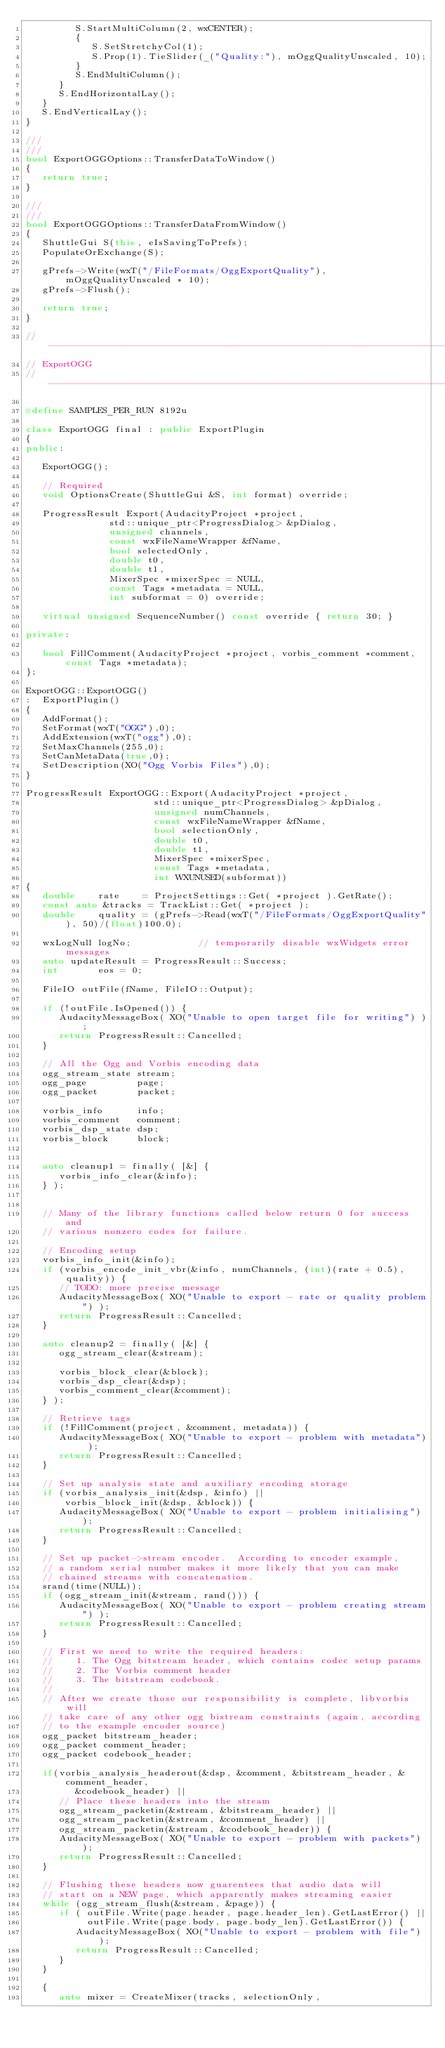<code> <loc_0><loc_0><loc_500><loc_500><_C++_>         S.StartMultiColumn(2, wxCENTER);
         {
            S.SetStretchyCol(1);
            S.Prop(1).TieSlider(_("Quality:"), mOggQualityUnscaled, 10);
         }
         S.EndMultiColumn();
      }
      S.EndHorizontalLay();
   }
   S.EndVerticalLay();
}

///
///
bool ExportOGGOptions::TransferDataToWindow()
{
   return true;
}

///
///
bool ExportOGGOptions::TransferDataFromWindow()
{
   ShuttleGui S(this, eIsSavingToPrefs);
   PopulateOrExchange(S);

   gPrefs->Write(wxT("/FileFormats/OggExportQuality"),mOggQualityUnscaled * 10);
   gPrefs->Flush();

   return true;
}

//----------------------------------------------------------------------------
// ExportOGG
//----------------------------------------------------------------------------

#define SAMPLES_PER_RUN 8192u

class ExportOGG final : public ExportPlugin
{
public:

   ExportOGG();

   // Required
   void OptionsCreate(ShuttleGui &S, int format) override;

   ProgressResult Export(AudacityProject *project,
               std::unique_ptr<ProgressDialog> &pDialog,
               unsigned channels,
               const wxFileNameWrapper &fName,
               bool selectedOnly,
               double t0,
               double t1,
               MixerSpec *mixerSpec = NULL,
               const Tags *metadata = NULL,
               int subformat = 0) override;

   virtual unsigned SequenceNumber() const override { return 30; }

private:

   bool FillComment(AudacityProject *project, vorbis_comment *comment, const Tags *metadata);
};

ExportOGG::ExportOGG()
:  ExportPlugin()
{
   AddFormat();
   SetFormat(wxT("OGG"),0);
   AddExtension(wxT("ogg"),0);
   SetMaxChannels(255,0);
   SetCanMetaData(true,0);
   SetDescription(XO("Ogg Vorbis Files"),0);
}

ProgressResult ExportOGG::Export(AudacityProject *project,
                       std::unique_ptr<ProgressDialog> &pDialog,
                       unsigned numChannels,
                       const wxFileNameWrapper &fName,
                       bool selectionOnly,
                       double t0,
                       double t1,
                       MixerSpec *mixerSpec,
                       const Tags *metadata,
                       int WXUNUSED(subformat))
{
   double    rate    = ProjectSettings::Get( *project ).GetRate();
   const auto &tracks = TrackList::Get( *project );
   double    quality = (gPrefs->Read(wxT("/FileFormats/OggExportQuality"), 50)/(float)100.0);

   wxLogNull logNo;            // temporarily disable wxWidgets error messages
   auto updateResult = ProgressResult::Success;
   int       eos = 0;

   FileIO outFile(fName, FileIO::Output);

   if (!outFile.IsOpened()) {
      AudacityMessageBox( XO("Unable to open target file for writing") );
      return ProgressResult::Cancelled;
   }

   // All the Ogg and Vorbis encoding data
   ogg_stream_state stream;
   ogg_page         page;
   ogg_packet       packet;

   vorbis_info      info;
   vorbis_comment   comment;
   vorbis_dsp_state dsp;
   vorbis_block     block;


   auto cleanup1 = finally( [&] {
      vorbis_info_clear(&info);
   } );


   // Many of the library functions called below return 0 for success and
   // various nonzero codes for failure.

   // Encoding setup
   vorbis_info_init(&info);
   if (vorbis_encode_init_vbr(&info, numChannels, (int)(rate + 0.5), quality)) {
      // TODO: more precise message
      AudacityMessageBox( XO("Unable to export - rate or quality problem") );
      return ProgressResult::Cancelled;
   }

   auto cleanup2 = finally( [&] {
      ogg_stream_clear(&stream);

      vorbis_block_clear(&block);
      vorbis_dsp_clear(&dsp);
      vorbis_comment_clear(&comment);
   } );

   // Retrieve tags
   if (!FillComment(project, &comment, metadata)) {
      AudacityMessageBox( XO("Unable to export - problem with metadata") );
      return ProgressResult::Cancelled;
   }

   // Set up analysis state and auxiliary encoding storage
   if (vorbis_analysis_init(&dsp, &info) ||
       vorbis_block_init(&dsp, &block)) {
      AudacityMessageBox( XO("Unable to export - problem initialising") );
      return ProgressResult::Cancelled;
   }

   // Set up packet->stream encoder.  According to encoder example,
   // a random serial number makes it more likely that you can make
   // chained streams with concatenation.
   srand(time(NULL));
   if (ogg_stream_init(&stream, rand())) {
      AudacityMessageBox( XO("Unable to export - problem creating stream") );
      return ProgressResult::Cancelled;
   }

   // First we need to write the required headers:
   //    1. The Ogg bitstream header, which contains codec setup params
   //    2. The Vorbis comment header
   //    3. The bitstream codebook.
   //
   // After we create those our responsibility is complete, libvorbis will
   // take care of any other ogg bistream constraints (again, according
   // to the example encoder source)
   ogg_packet bitstream_header;
   ogg_packet comment_header;
   ogg_packet codebook_header;

   if(vorbis_analysis_headerout(&dsp, &comment, &bitstream_header, &comment_header,
         &codebook_header) ||
      // Place these headers into the stream
      ogg_stream_packetin(&stream, &bitstream_header) ||
      ogg_stream_packetin(&stream, &comment_header) ||
      ogg_stream_packetin(&stream, &codebook_header)) {
      AudacityMessageBox( XO("Unable to export - problem with packets") );
      return ProgressResult::Cancelled;
   }

   // Flushing these headers now guarentees that audio data will
   // start on a NEW page, which apparently makes streaming easier
   while (ogg_stream_flush(&stream, &page)) {
      if ( outFile.Write(page.header, page.header_len).GetLastError() ||
           outFile.Write(page.body, page.body_len).GetLastError()) {
         AudacityMessageBox( XO("Unable to export - problem with file") );
         return ProgressResult::Cancelled;
      }
   }

   {
      auto mixer = CreateMixer(tracks, selectionOnly,</code> 